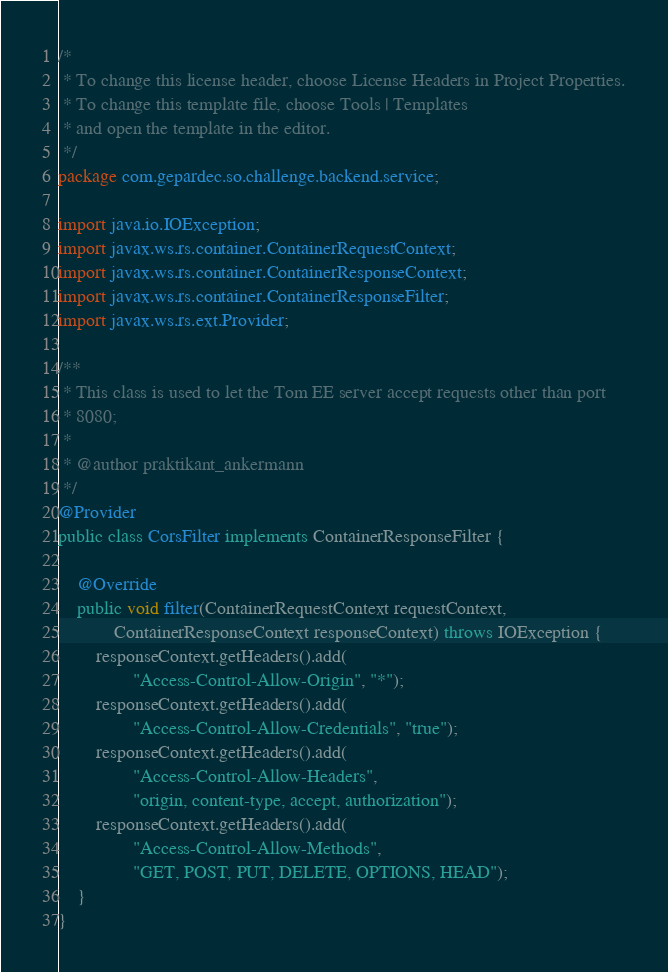Convert code to text. <code><loc_0><loc_0><loc_500><loc_500><_Java_>/*
 * To change this license header, choose License Headers in Project Properties.
 * To change this template file, choose Tools | Templates
 * and open the template in the editor.
 */
package com.gepardec.so.challenge.backend.service;

import java.io.IOException;
import javax.ws.rs.container.ContainerRequestContext;
import javax.ws.rs.container.ContainerResponseContext;
import javax.ws.rs.container.ContainerResponseFilter;
import javax.ws.rs.ext.Provider;

/**
 * This class is used to let the Tom EE server accept requests other than port
 * 8080;
 *
 * @author praktikant_ankermann
 */
@Provider
public class CorsFilter implements ContainerResponseFilter {

    @Override
    public void filter(ContainerRequestContext requestContext,
            ContainerResponseContext responseContext) throws IOException {
        responseContext.getHeaders().add(
                "Access-Control-Allow-Origin", "*");
        responseContext.getHeaders().add(
                "Access-Control-Allow-Credentials", "true");
        responseContext.getHeaders().add(
                "Access-Control-Allow-Headers",
                "origin, content-type, accept, authorization");
        responseContext.getHeaders().add(
                "Access-Control-Allow-Methods",
                "GET, POST, PUT, DELETE, OPTIONS, HEAD");
    }
}
</code> 